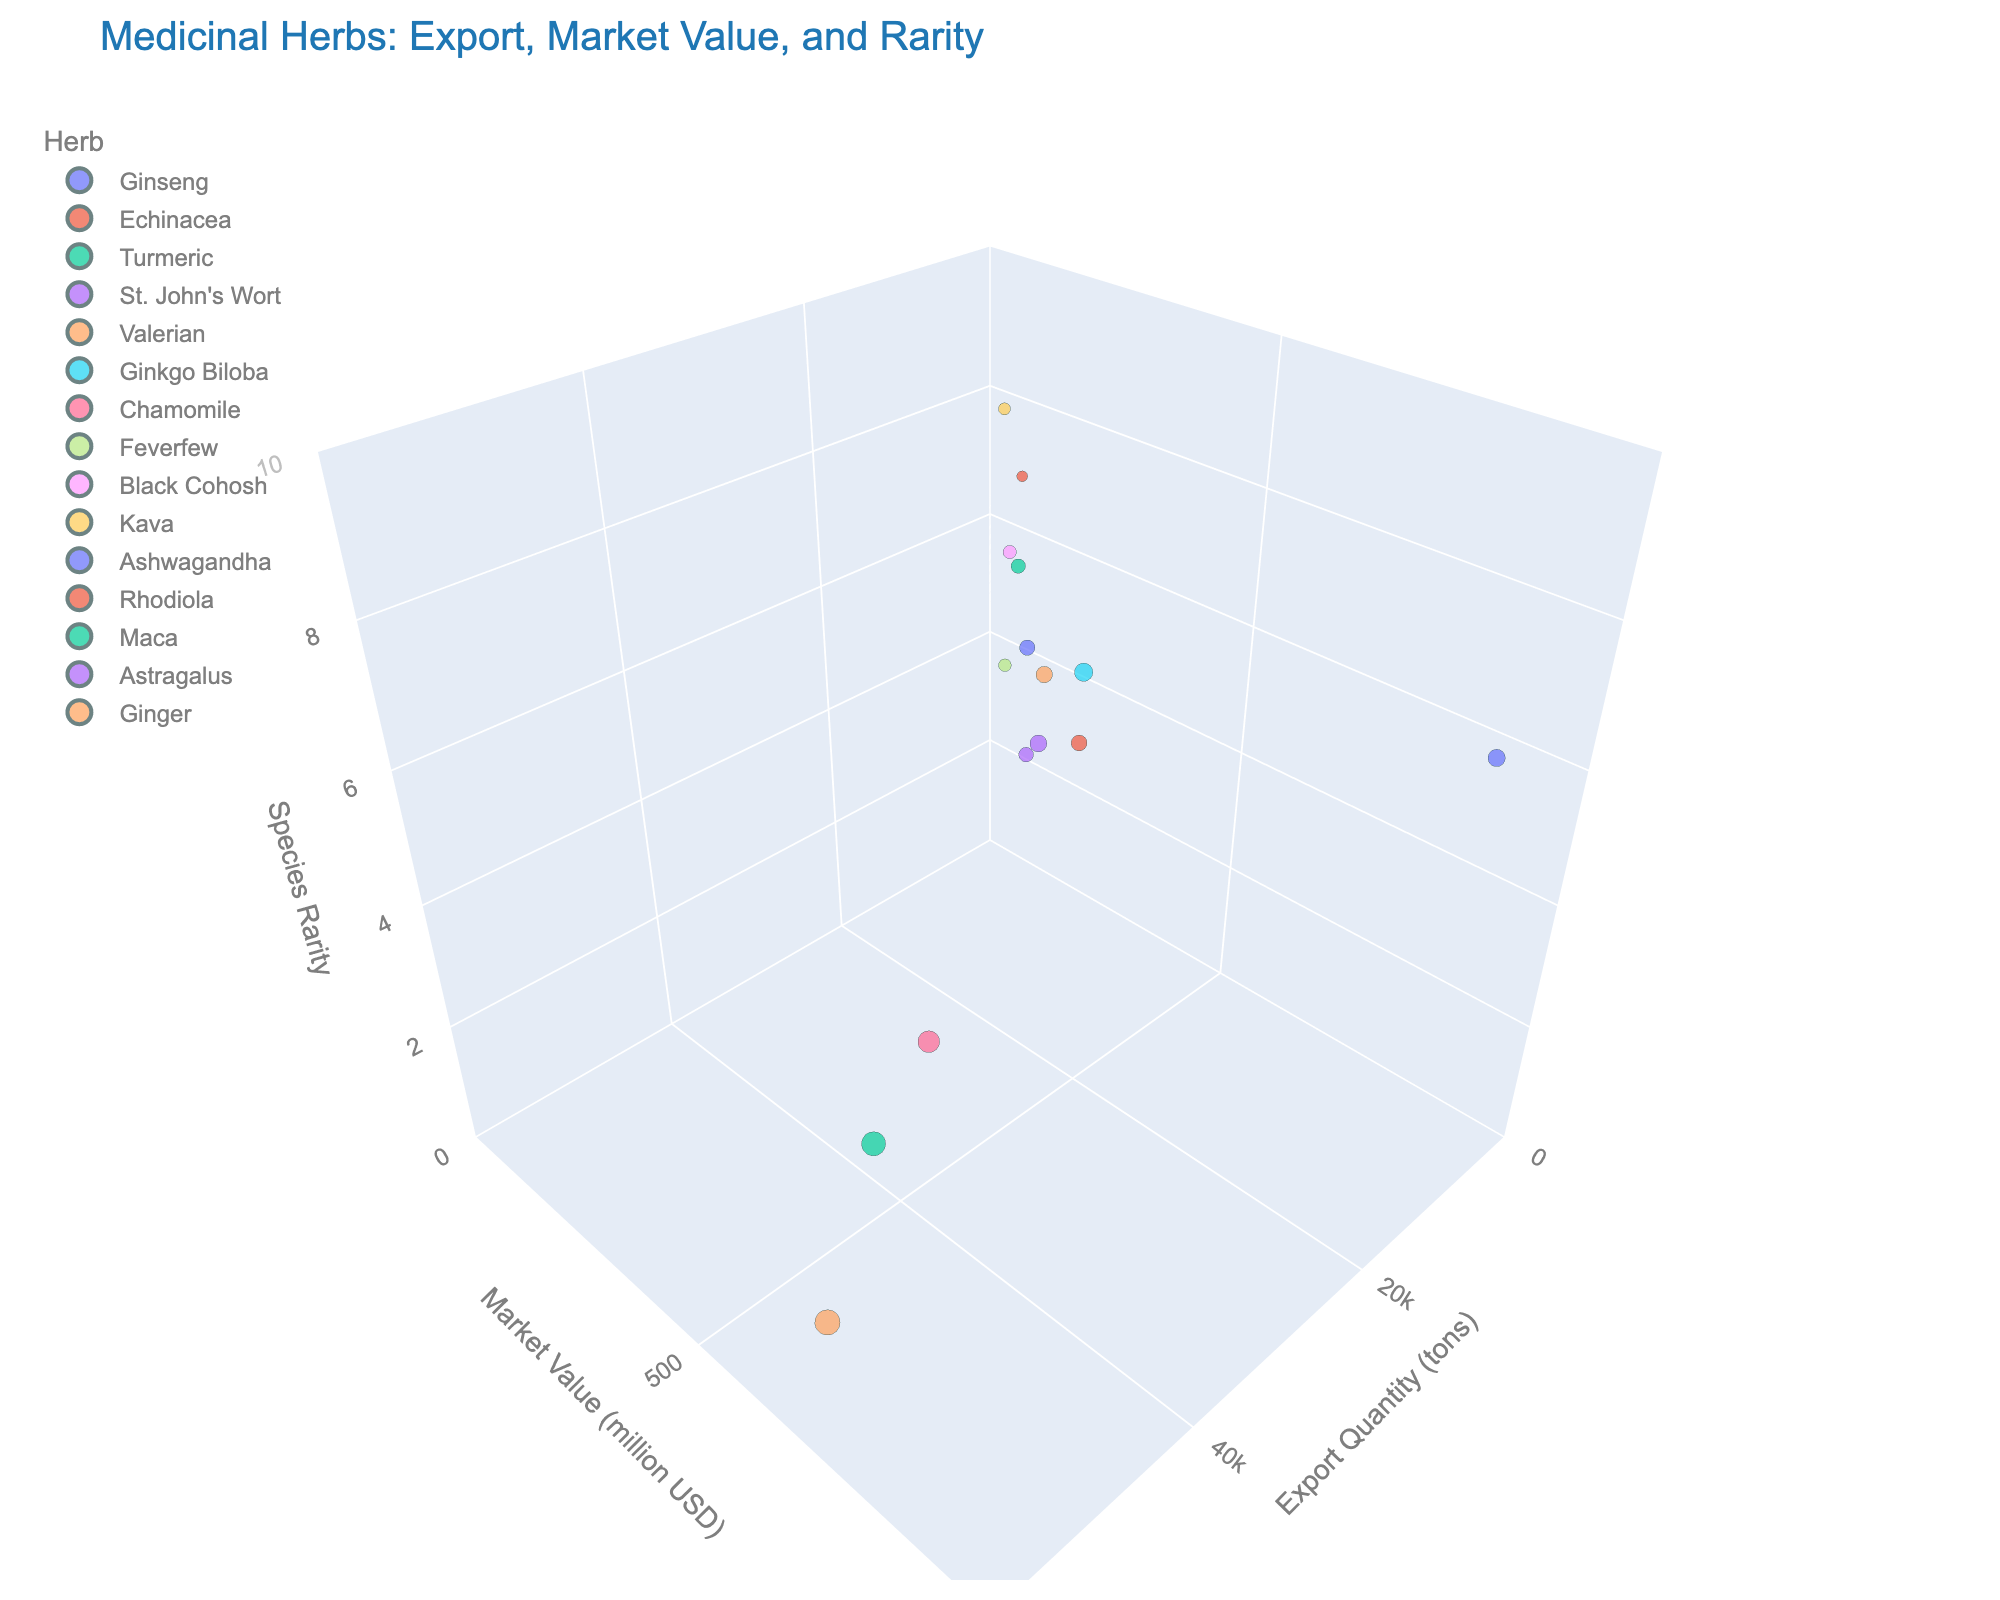What is the title of the figure? The title is written at the top of the figure and usually summarizes the content of the plot.
Answer: Medicinal Herbs: Export, Market Value, and Rarity Which herb has the highest export quantity? Look at the x-axis (Export Quantity) and find the herb farthest to the right.
Answer: Ginger What is the species rarity of Ginseng? Locate Ginseng's bubble on the chart and check the z-axis (Species Rarity) value.
Answer: 7 How many herbs have a market value greater than 300 million USD? Identify the bubbles above the 300 million USD mark on the y-axis (Market Value).
Answer: 4 Which herb has the least market value? Find the bubble that is lowest on the y-axis (Market Value).
Answer: Kava What is the average export quantity of Chamomile and Turmeric? Chamomile's export quantity is 30000 tons, Turmeric's is 45000 tons. The average is (30000 + 45000) / 2 = 37500 tons.
Answer: 37500 tons Compare the rarity of Black Cohosh and Rhodiola. Which one is rarer? Find the z-axis value (Species Rarity) for both herbs and compare. Black Cohosh is 6, Rhodiola is 7.
Answer: Rhodiola Which herb has a higher market value, Valerian or Feverfew? Check the y-axis values for Valerian and Feverfew. Valerian is at 270 million USD, Feverfew is at 90 million USD.
Answer: Valerian What is the total number of herbs shown in the figure? Count the number of bubbles present in the 3D space.
Answer: 15 What is the relationship between Ashwagandha’s export quantity and species rarity? Find Ashwagandha’s bubble and compare its x-axis (Export Quantity) and z-axis (Species Rarity) values. It has a moderate export quantity and a medium rarity.
Answer: Moderate quantity, medium rarity Out of Ginkgo Biloba and Astragalus, which has a higher market value and what is the difference? Ginkgo Biloba’s market value is 420 million USD, Astragalus’s is 280 million USD. The difference is 420 - 280 = 140 million USD.
Answer: Ginkgo Biloba, 140 million USD 